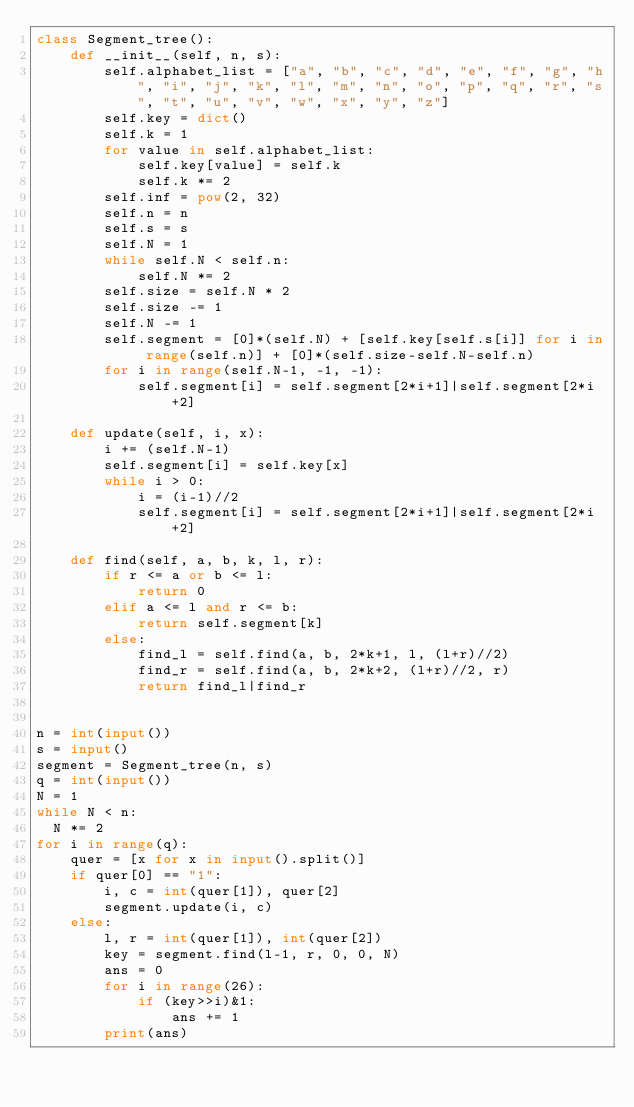Convert code to text. <code><loc_0><loc_0><loc_500><loc_500><_Python_>class Segment_tree():
    def __init__(self, n, s):
        self.alphabet_list = ["a", "b", "c", "d", "e", "f", "g", "h", "i", "j", "k", "l", "m", "n", "o", "p", "q", "r", "s", "t", "u", "v", "w", "x", "y", "z"]
        self.key = dict()
        self.k = 1
        for value in self.alphabet_list:
            self.key[value] = self.k
            self.k *= 2
        self.inf = pow(2, 32)
        self.n = n
        self.s = s
        self.N = 1
        while self.N < self.n:
            self.N *= 2
        self.size = self.N * 2
        self.size -= 1
        self.N -= 1
        self.segment = [0]*(self.N) + [self.key[self.s[i]] for i in range(self.n)] + [0]*(self.size-self.N-self.n)
        for i in range(self.N-1, -1, -1):
            self.segment[i] = self.segment[2*i+1]|self.segment[2*i+2]

    def update(self, i, x):
        i += (self.N-1)
        self.segment[i] = self.key[x]
        while i > 0:
            i = (i-1)//2
            self.segment[i] = self.segment[2*i+1]|self.segment[2*i+2]
        
    def find(self, a, b, k, l, r):
        if r <= a or b <= l:
            return 0
        elif a <= l and r <= b:
            return self.segment[k]
        else:
            find_l = self.find(a, b, 2*k+1, l, (l+r)//2)
            find_r = self.find(a, b, 2*k+2, (l+r)//2, r)
            return find_l|find_r


n = int(input())
s = input()
segment = Segment_tree(n, s)
q = int(input())
N = 1
while N < n:
  N *= 2
for i in range(q):
    quer = [x for x in input().split()]
    if quer[0] == "1":
        i, c = int(quer[1]), quer[2]
        segment.update(i, c)
    else:
        l, r = int(quer[1]), int(quer[2])
        key = segment.find(l-1, r, 0, 0, N)
        ans = 0
        for i in range(26):
            if (key>>i)&1:
                ans += 1
        print(ans)</code> 